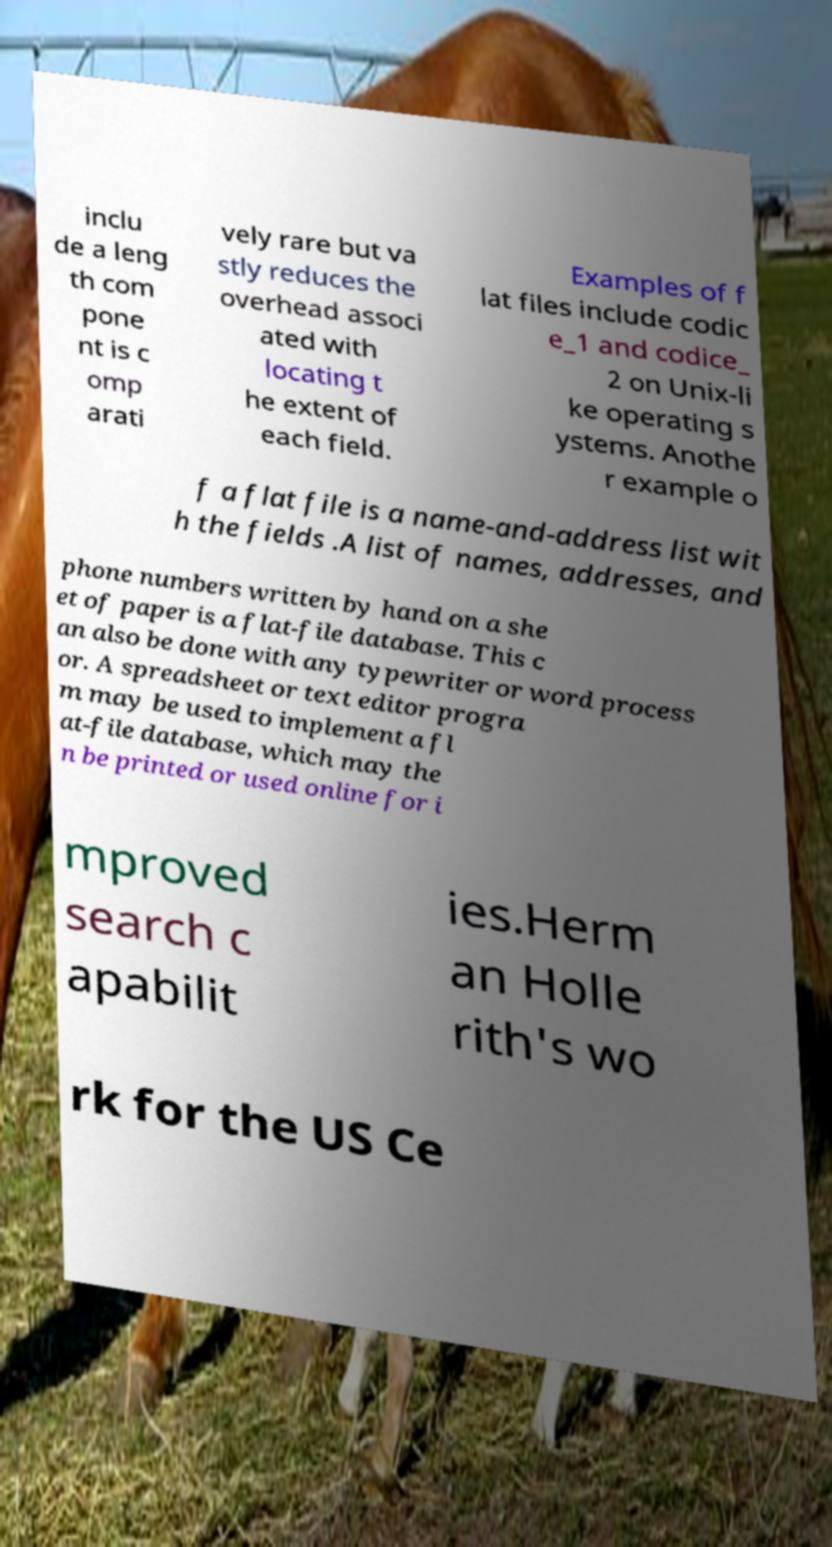Can you accurately transcribe the text from the provided image for me? inclu de a leng th com pone nt is c omp arati vely rare but va stly reduces the overhead associ ated with locating t he extent of each field. Examples of f lat files include codic e_1 and codice_ 2 on Unix-li ke operating s ystems. Anothe r example o f a flat file is a name-and-address list wit h the fields .A list of names, addresses, and phone numbers written by hand on a she et of paper is a flat-file database. This c an also be done with any typewriter or word process or. A spreadsheet or text editor progra m may be used to implement a fl at-file database, which may the n be printed or used online for i mproved search c apabilit ies.Herm an Holle rith's wo rk for the US Ce 